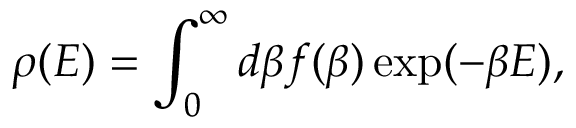Convert formula to latex. <formula><loc_0><loc_0><loc_500><loc_500>\rho ( E ) = \int _ { 0 } ^ { \infty } d \beta f ( \beta ) \exp ( - \beta E ) ,</formula> 